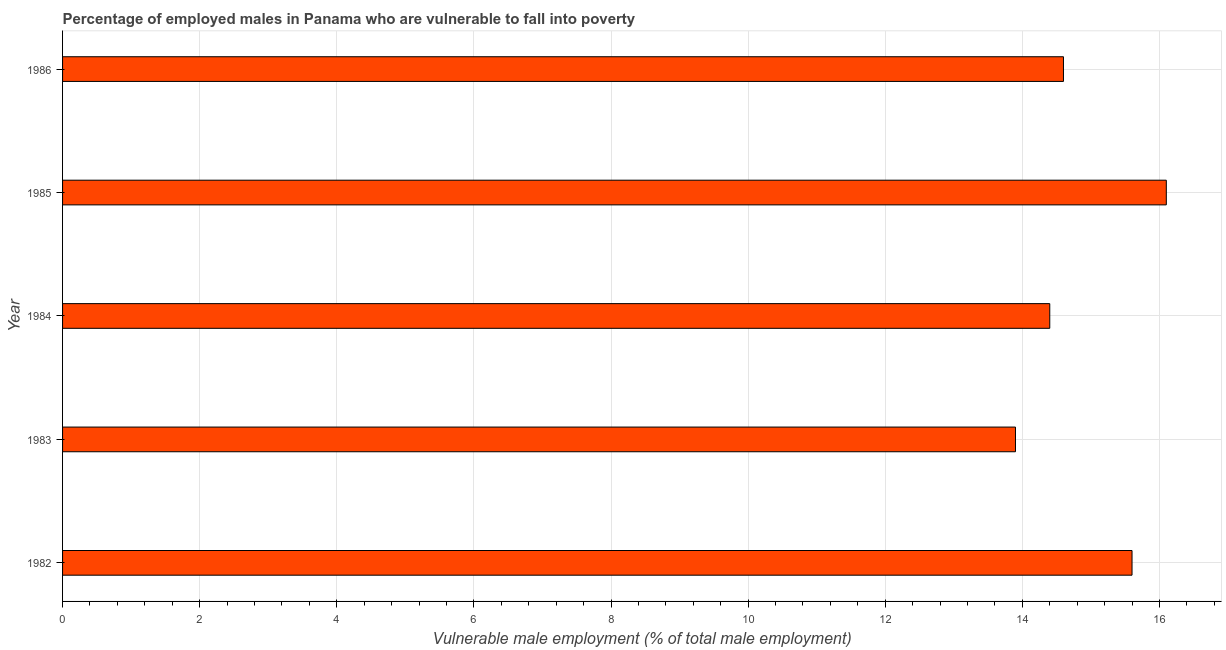What is the title of the graph?
Offer a very short reply. Percentage of employed males in Panama who are vulnerable to fall into poverty. What is the label or title of the X-axis?
Your response must be concise. Vulnerable male employment (% of total male employment). What is the percentage of employed males who are vulnerable to fall into poverty in 1982?
Make the answer very short. 15.6. Across all years, what is the maximum percentage of employed males who are vulnerable to fall into poverty?
Your response must be concise. 16.1. Across all years, what is the minimum percentage of employed males who are vulnerable to fall into poverty?
Make the answer very short. 13.9. What is the sum of the percentage of employed males who are vulnerable to fall into poverty?
Your answer should be very brief. 74.6. What is the difference between the percentage of employed males who are vulnerable to fall into poverty in 1985 and 1986?
Your answer should be compact. 1.5. What is the average percentage of employed males who are vulnerable to fall into poverty per year?
Offer a very short reply. 14.92. What is the median percentage of employed males who are vulnerable to fall into poverty?
Provide a short and direct response. 14.6. In how many years, is the percentage of employed males who are vulnerable to fall into poverty greater than 7.6 %?
Your answer should be very brief. 5. Do a majority of the years between 1986 and 1982 (inclusive) have percentage of employed males who are vulnerable to fall into poverty greater than 12.8 %?
Provide a succinct answer. Yes. What is the ratio of the percentage of employed males who are vulnerable to fall into poverty in 1985 to that in 1986?
Offer a very short reply. 1.1. Is the percentage of employed males who are vulnerable to fall into poverty in 1983 less than that in 1986?
Your response must be concise. Yes. Is the difference between the percentage of employed males who are vulnerable to fall into poverty in 1982 and 1986 greater than the difference between any two years?
Provide a succinct answer. No. What is the difference between the highest and the second highest percentage of employed males who are vulnerable to fall into poverty?
Provide a short and direct response. 0.5. Is the sum of the percentage of employed males who are vulnerable to fall into poverty in 1982 and 1985 greater than the maximum percentage of employed males who are vulnerable to fall into poverty across all years?
Offer a terse response. Yes. What is the difference between the highest and the lowest percentage of employed males who are vulnerable to fall into poverty?
Keep it short and to the point. 2.2. In how many years, is the percentage of employed males who are vulnerable to fall into poverty greater than the average percentage of employed males who are vulnerable to fall into poverty taken over all years?
Your answer should be compact. 2. How many years are there in the graph?
Your response must be concise. 5. What is the difference between two consecutive major ticks on the X-axis?
Provide a short and direct response. 2. What is the Vulnerable male employment (% of total male employment) of 1982?
Provide a succinct answer. 15.6. What is the Vulnerable male employment (% of total male employment) of 1983?
Provide a short and direct response. 13.9. What is the Vulnerable male employment (% of total male employment) in 1984?
Offer a very short reply. 14.4. What is the Vulnerable male employment (% of total male employment) in 1985?
Give a very brief answer. 16.1. What is the Vulnerable male employment (% of total male employment) of 1986?
Keep it short and to the point. 14.6. What is the difference between the Vulnerable male employment (% of total male employment) in 1982 and 1985?
Keep it short and to the point. -0.5. What is the difference between the Vulnerable male employment (% of total male employment) in 1985 and 1986?
Ensure brevity in your answer.  1.5. What is the ratio of the Vulnerable male employment (% of total male employment) in 1982 to that in 1983?
Offer a very short reply. 1.12. What is the ratio of the Vulnerable male employment (% of total male employment) in 1982 to that in 1984?
Offer a very short reply. 1.08. What is the ratio of the Vulnerable male employment (% of total male employment) in 1982 to that in 1986?
Ensure brevity in your answer.  1.07. What is the ratio of the Vulnerable male employment (% of total male employment) in 1983 to that in 1984?
Give a very brief answer. 0.96. What is the ratio of the Vulnerable male employment (% of total male employment) in 1983 to that in 1985?
Provide a succinct answer. 0.86. What is the ratio of the Vulnerable male employment (% of total male employment) in 1983 to that in 1986?
Your answer should be compact. 0.95. What is the ratio of the Vulnerable male employment (% of total male employment) in 1984 to that in 1985?
Make the answer very short. 0.89. What is the ratio of the Vulnerable male employment (% of total male employment) in 1984 to that in 1986?
Provide a short and direct response. 0.99. What is the ratio of the Vulnerable male employment (% of total male employment) in 1985 to that in 1986?
Give a very brief answer. 1.1. 